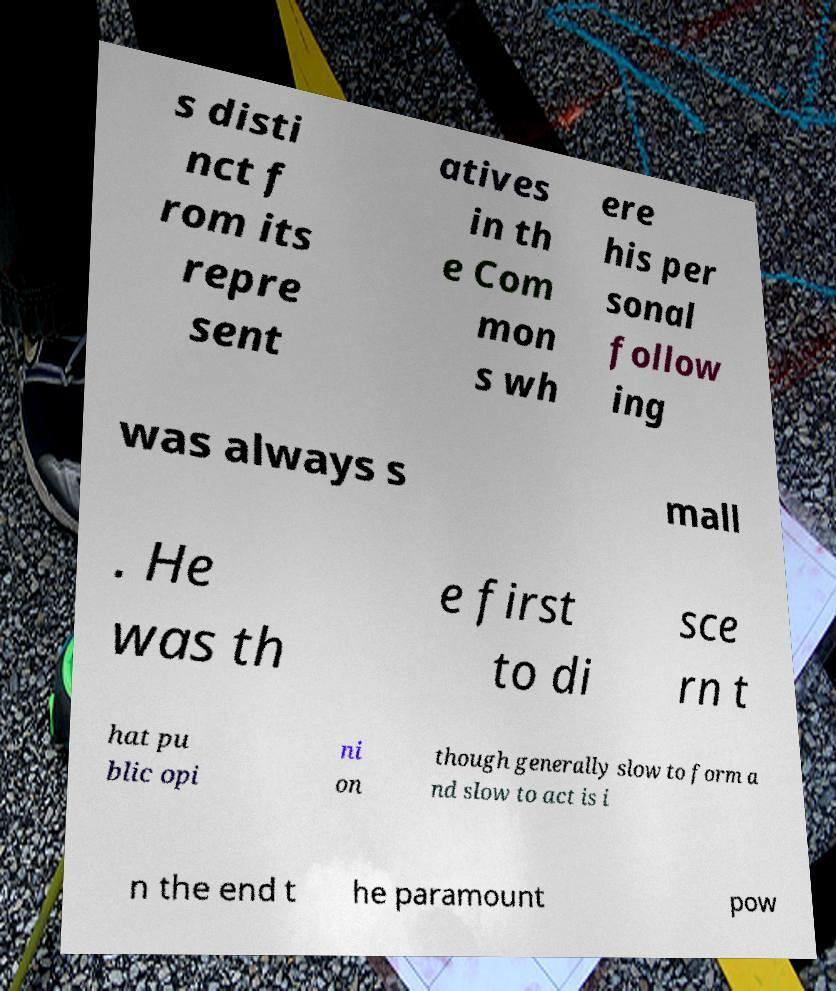Please identify and transcribe the text found in this image. s disti nct f rom its repre sent atives in th e Com mon s wh ere his per sonal follow ing was always s mall . He was th e first to di sce rn t hat pu blic opi ni on though generally slow to form a nd slow to act is i n the end t he paramount pow 